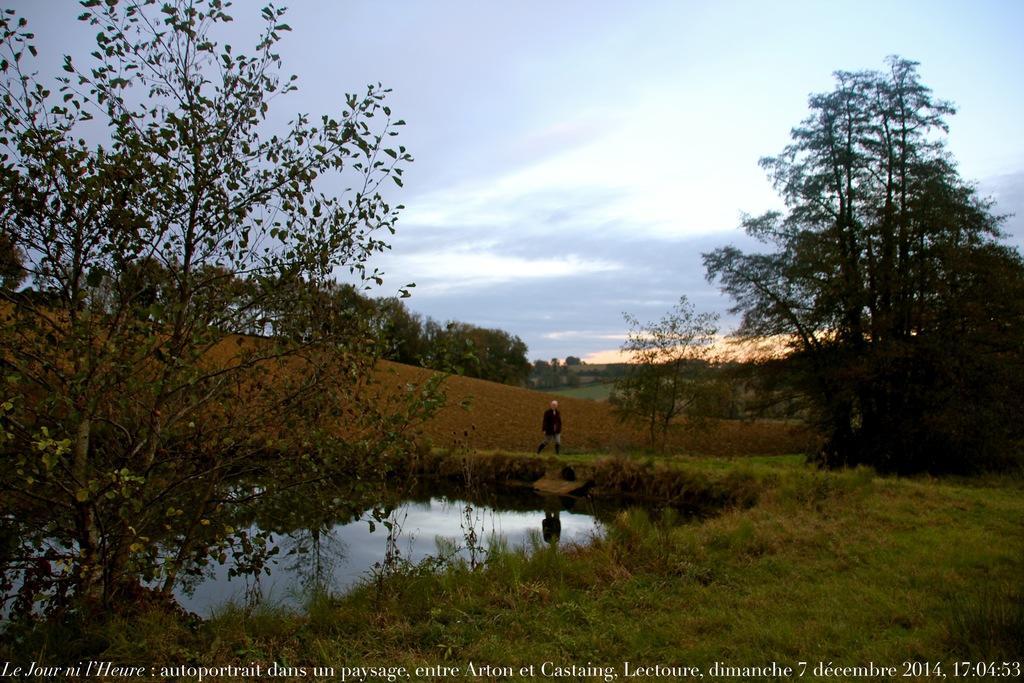How would you summarize this image in a sentence or two? In this picture I can see a person standing, there is water, there are trees, and in the background there is the sky and there is a watermark on the image. 